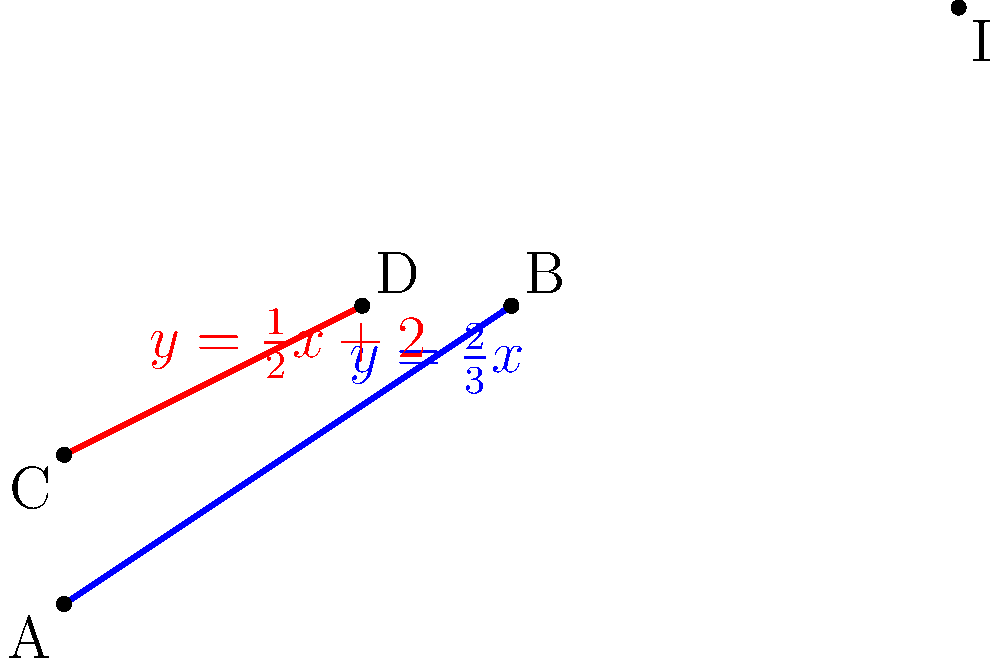In your latest special effects makeup tutorial, you're demonstrating how to create the perfect winged eyeliner. You explain that achieving the ideal wing is like finding the intersection of two lines. Consider two eyeliner strokes represented by the equations $y = \frac{2}{3}x$ and $y = \frac{1}{2}x + 2$. At what point $(x, y)$ do these lines intersect, representing the perfect tip of your winged eyeliner? To find the intersection point of these two lines, we need to solve the system of equations:

1) $y = \frac{2}{3}x$
2) $y = \frac{1}{2}x + 2$

Step 1: Set the right sides of the equations equal to each other:
$$\frac{2}{3}x = \frac{1}{2}x + 2$$

Step 2: Multiply both sides by 6 to eliminate fractions:
$$4x = 3x + 12$$

Step 3: Subtract 3x from both sides:
$$x = 12$$

Step 4: Substitute this x-value into either of the original equations. Let's use the first one:
$$y = \frac{2}{3}(12) = 8$$

Therefore, the intersection point, representing the perfect tip of the winged eyeliner, is at (12, 8).
Answer: (12, 8) 